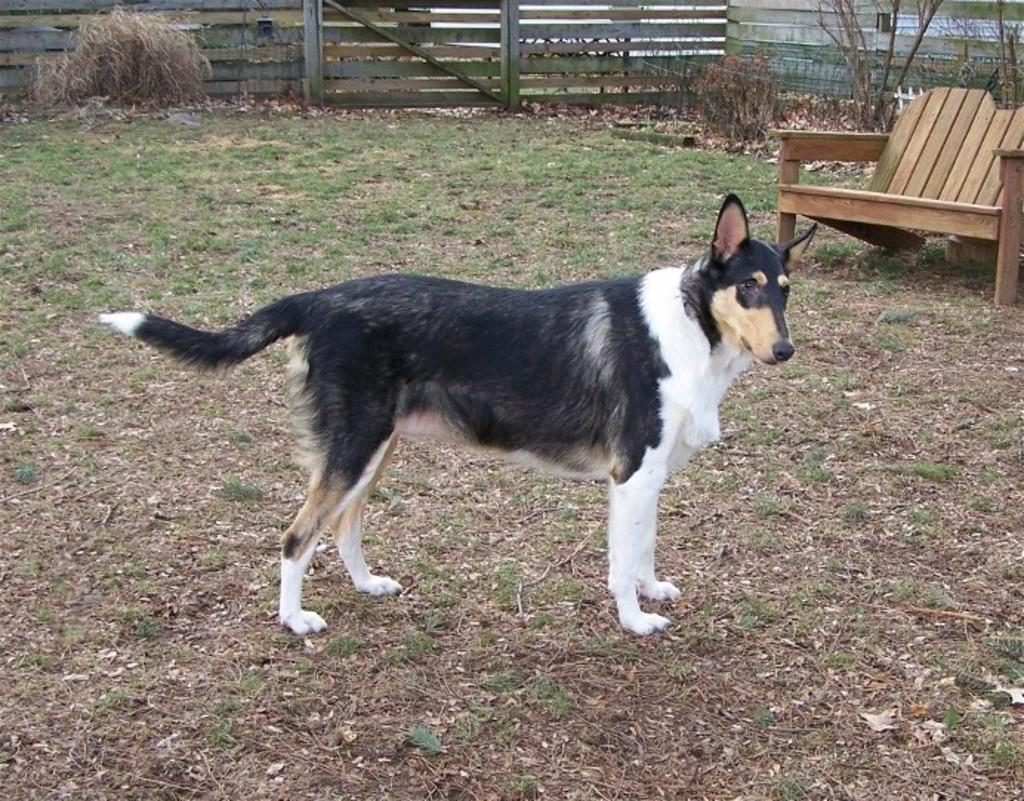What animal can be seen in the image? There is a dog in the image. What is the dog's position in relation to the ground? The dog is standing on the ground. What object is located beside the dog? There is a bench beside the dog. What is present at the back of the scene? There is a fencing at the back of the scene. What type of paste is being used by the family in the image? There is no family or paste present in the image; it features a dog standing on the ground with a bench beside it and fencing at the back. 